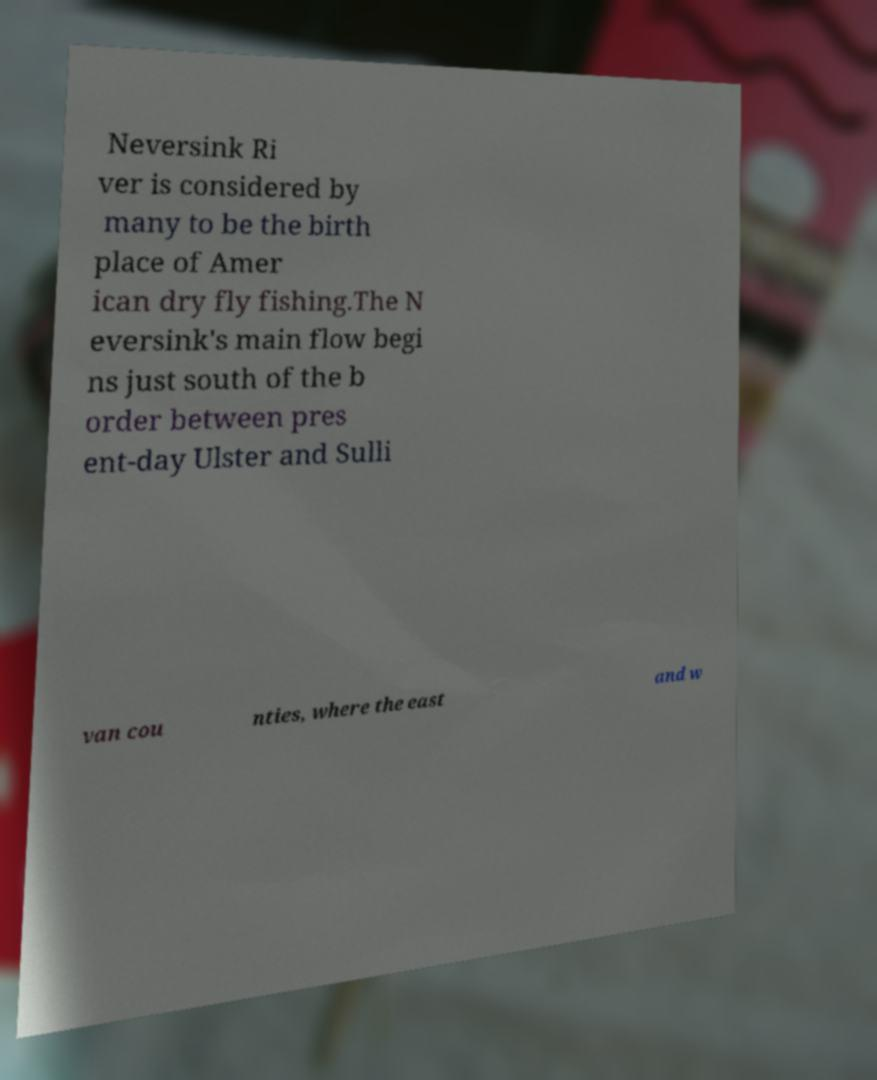For documentation purposes, I need the text within this image transcribed. Could you provide that? Neversink Ri ver is considered by many to be the birth place of Amer ican dry fly fishing.The N eversink's main flow begi ns just south of the b order between pres ent-day Ulster and Sulli van cou nties, where the east and w 